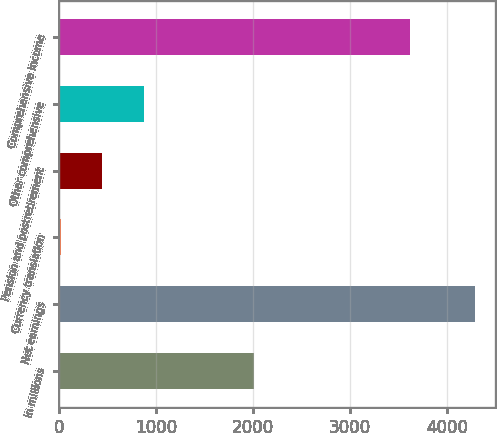Convert chart to OTSL. <chart><loc_0><loc_0><loc_500><loc_500><bar_chart><fcel>in millions<fcel>Net earnings<fcel>Currency translation<fcel>Pension and postretirement<fcel>Other comprehensive<fcel>Comprehensive income<nl><fcel>2017<fcel>4286<fcel>22<fcel>448.4<fcel>874.8<fcel>3622<nl></chart> 